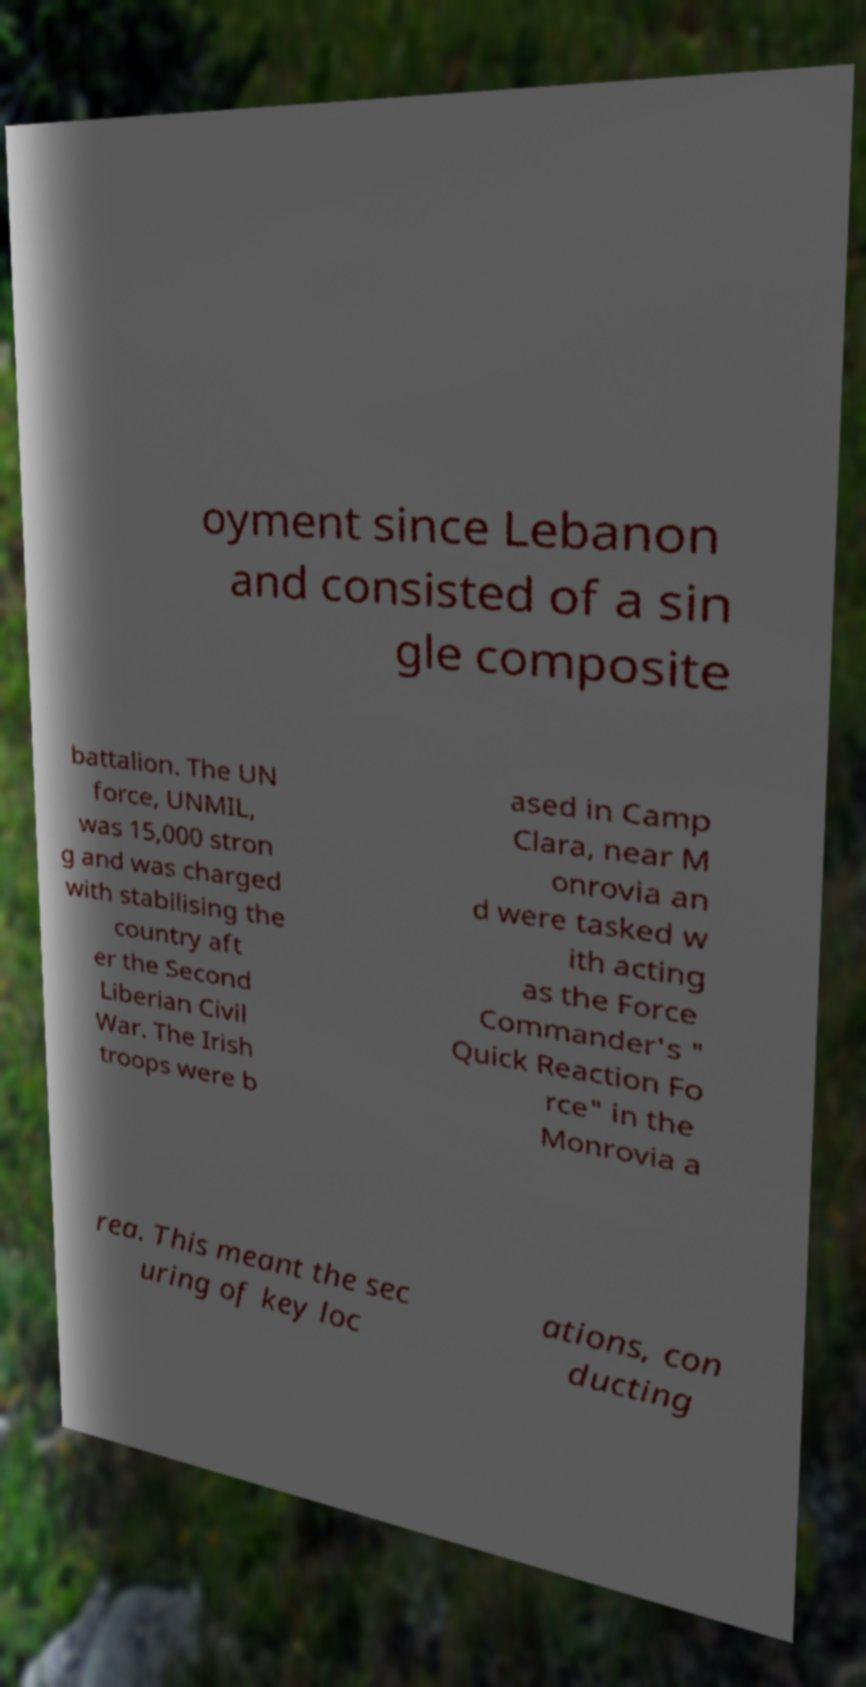Please read and relay the text visible in this image. What does it say? oyment since Lebanon and consisted of a sin gle composite battalion. The UN force, UNMIL, was 15,000 stron g and was charged with stabilising the country aft er the Second Liberian Civil War. The Irish troops were b ased in Camp Clara, near M onrovia an d were tasked w ith acting as the Force Commander's " Quick Reaction Fo rce" in the Monrovia a rea. This meant the sec uring of key loc ations, con ducting 